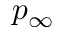Convert formula to latex. <formula><loc_0><loc_0><loc_500><loc_500>p _ { \infty }</formula> 